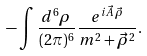<formula> <loc_0><loc_0><loc_500><loc_500>- \int \frac { d ^ { 6 } \rho } { ( 2 \pi ) ^ { 6 } } \, \frac { e ^ { i \vec { A } \, \vec { \rho } } } { m ^ { 2 } + \vec { \rho } ^ { 2 } } .</formula> 